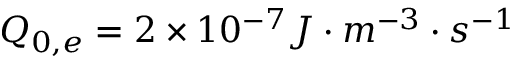Convert formula to latex. <formula><loc_0><loc_0><loc_500><loc_500>Q _ { 0 , e } = 2 \times 1 0 ^ { - 7 } J \cdot m ^ { - 3 } \cdot s ^ { - 1 }</formula> 